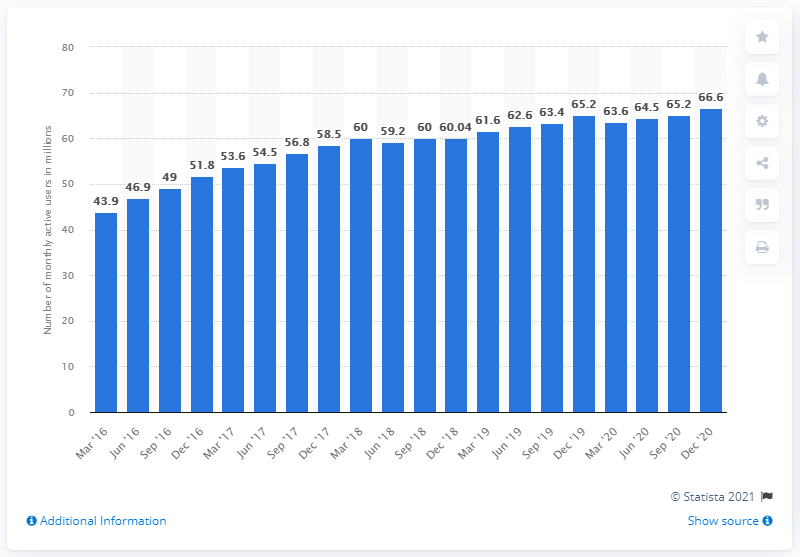Specify some key components in this picture. As of December 2020, VKontakte had approximately 66.6 million active mobile users. 